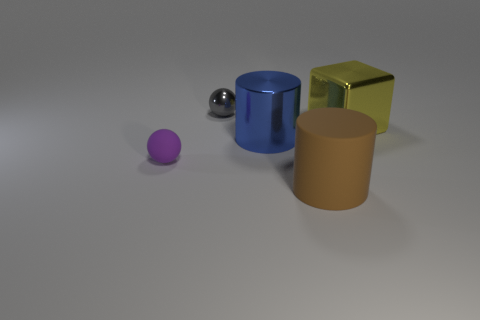There is a large object that is in front of the big yellow object and behind the purple object; what is its shape?
Your answer should be very brief. Cylinder. There is a tiny sphere behind the big thing that is left of the large thing in front of the big blue cylinder; what is it made of?
Offer a very short reply. Metal. Is the number of matte objects in front of the purple matte sphere greater than the number of large blocks that are on the right side of the large cube?
Provide a short and direct response. Yes. How many big green objects have the same material as the big yellow block?
Provide a succinct answer. 0. Do the small thing behind the block and the large metallic thing that is right of the blue shiny cylinder have the same shape?
Provide a succinct answer. No. What color is the cylinder behind the small purple matte sphere?
Keep it short and to the point. Blue. Is there a tiny blue matte thing of the same shape as the big brown thing?
Keep it short and to the point. No. What is the tiny gray sphere made of?
Your answer should be compact. Metal. How big is the thing that is to the right of the big blue metal object and in front of the block?
Provide a succinct answer. Large. How many blue metallic things are there?
Provide a succinct answer. 1. 